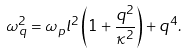<formula> <loc_0><loc_0><loc_500><loc_500>\omega _ { q } ^ { 2 } = \omega _ { p } l ^ { 2 } \left ( 1 + \frac { q ^ { 2 } } { \kappa ^ { 2 } } \right ) + q ^ { 4 } .</formula> 